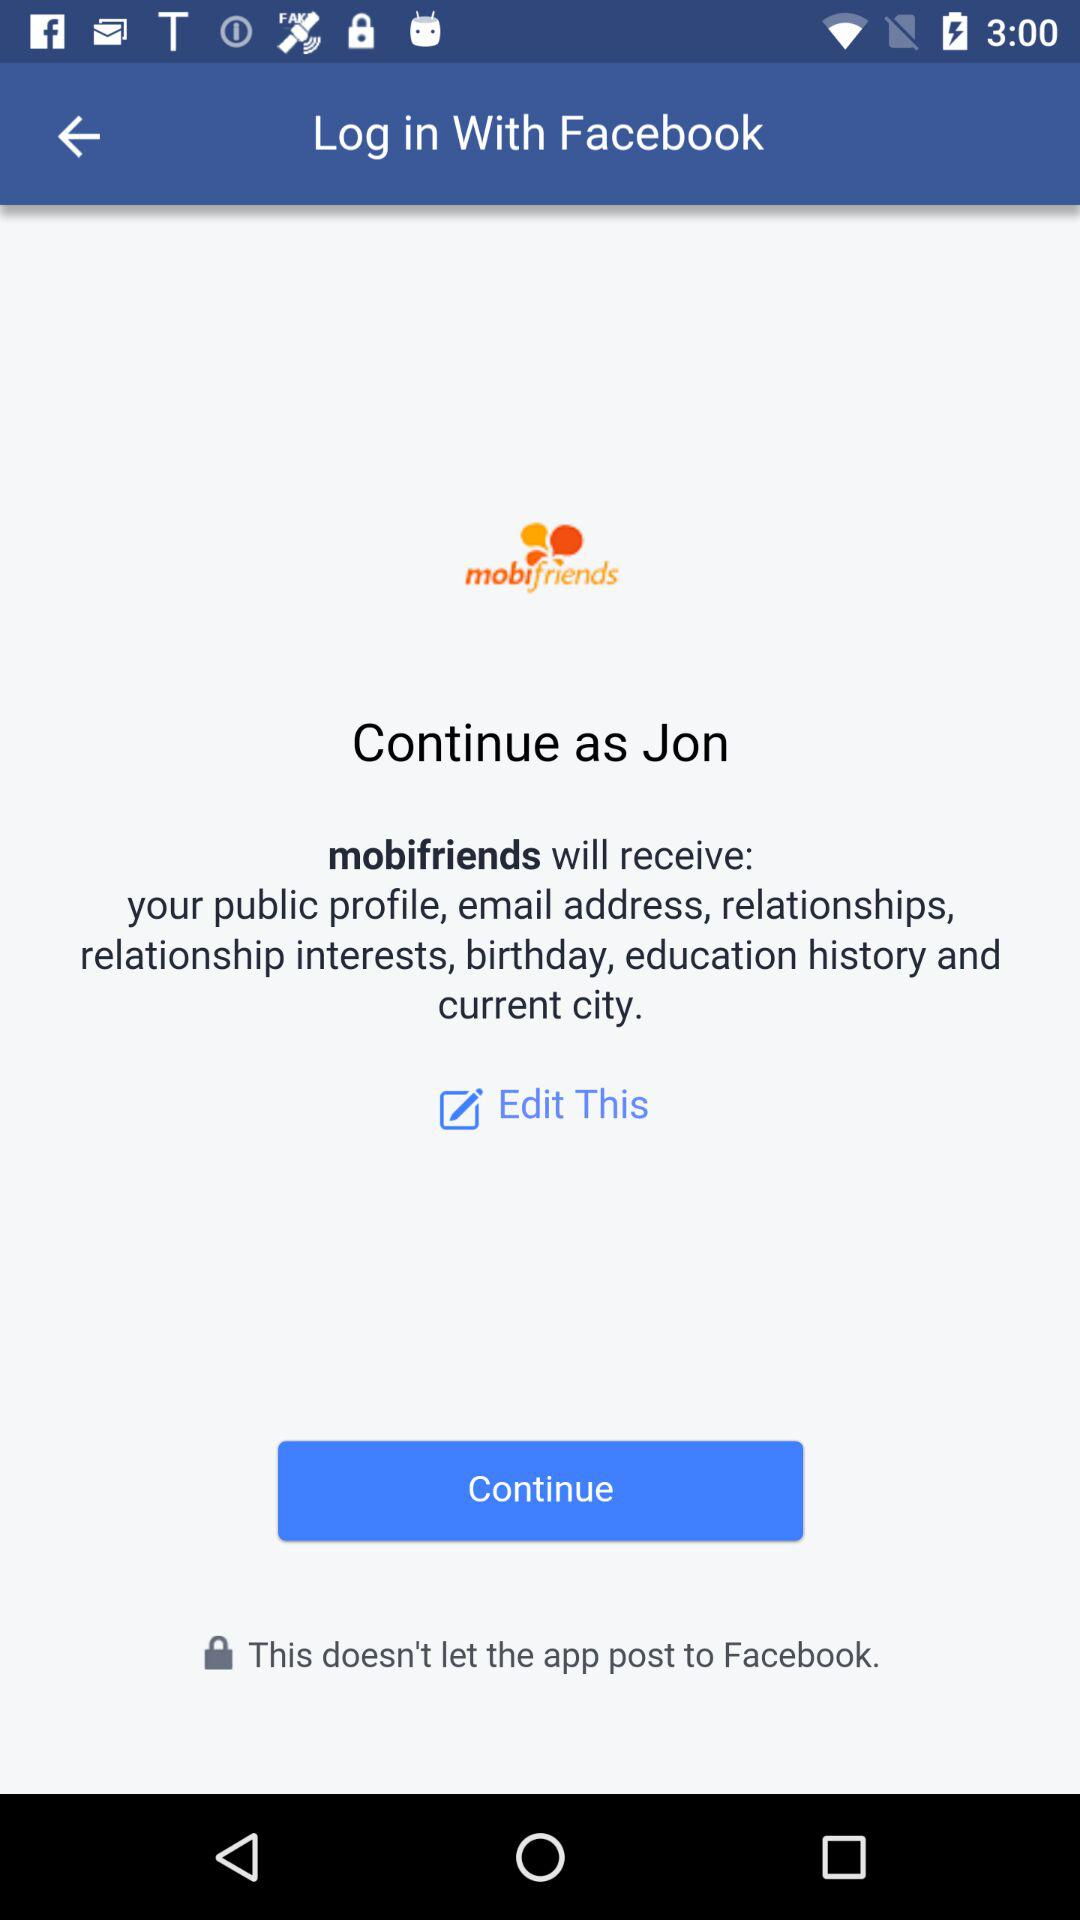What application is asking for permission? The application is "mobifriends". 